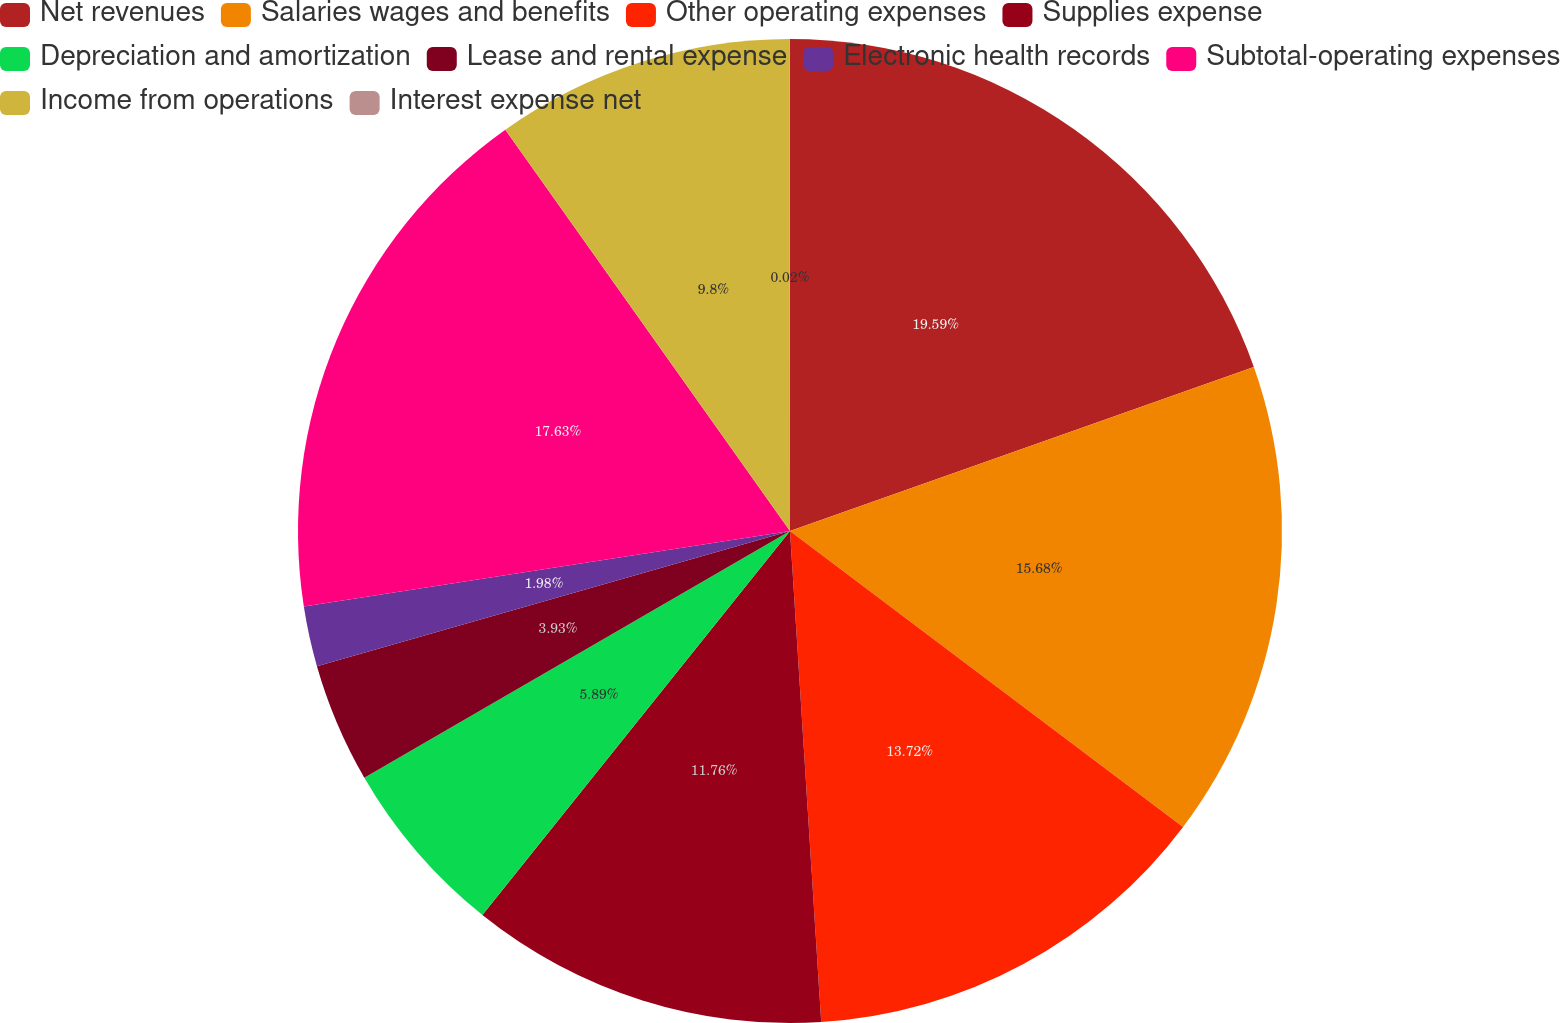Convert chart. <chart><loc_0><loc_0><loc_500><loc_500><pie_chart><fcel>Net revenues<fcel>Salaries wages and benefits<fcel>Other operating expenses<fcel>Supplies expense<fcel>Depreciation and amortization<fcel>Lease and rental expense<fcel>Electronic health records<fcel>Subtotal-operating expenses<fcel>Income from operations<fcel>Interest expense net<nl><fcel>19.59%<fcel>15.68%<fcel>13.72%<fcel>11.76%<fcel>5.89%<fcel>3.93%<fcel>1.98%<fcel>17.63%<fcel>9.8%<fcel>0.02%<nl></chart> 